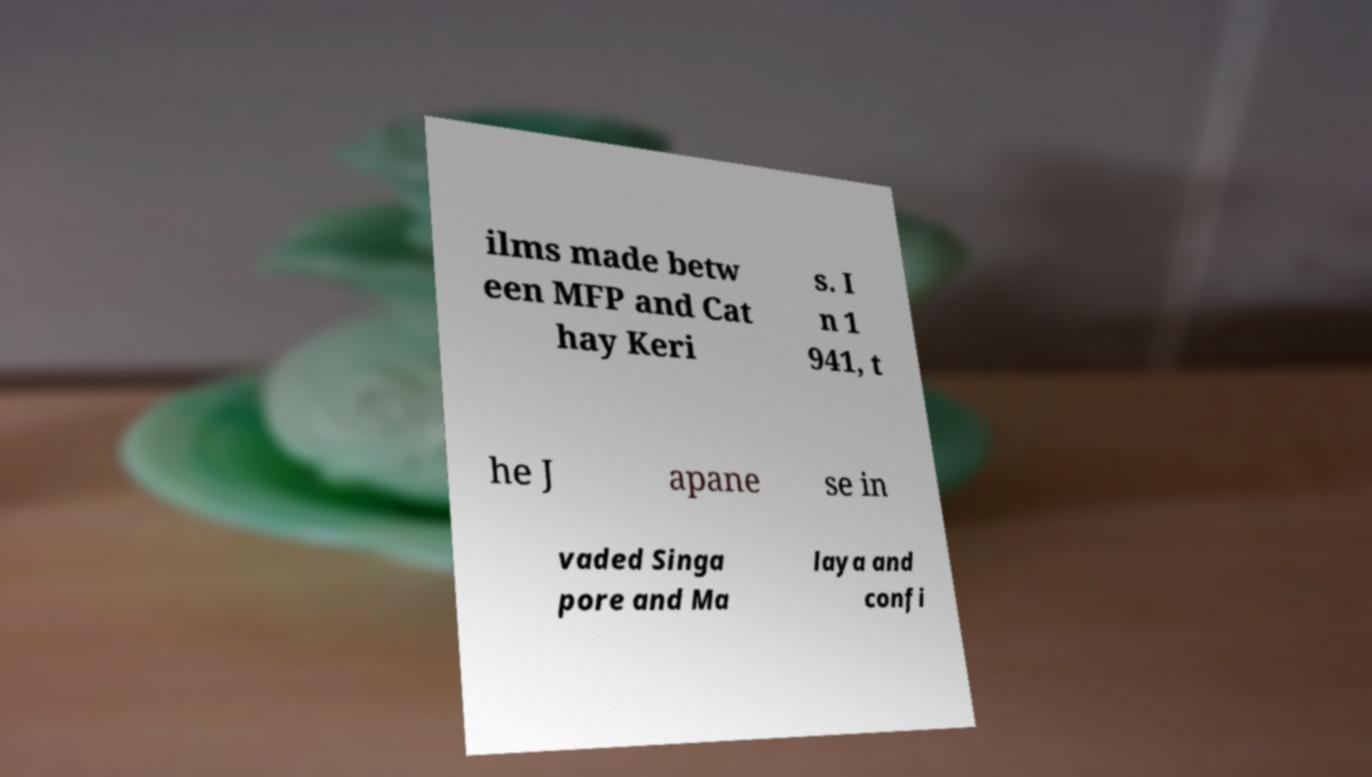Can you read and provide the text displayed in the image?This photo seems to have some interesting text. Can you extract and type it out for me? ilms made betw een MFP and Cat hay Keri s. I n 1 941, t he J apane se in vaded Singa pore and Ma laya and confi 